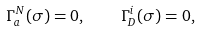Convert formula to latex. <formula><loc_0><loc_0><loc_500><loc_500>\Gamma ^ { N } _ { a } ( \sigma ) = 0 , \quad \Gamma ^ { i } _ { D } ( \sigma ) = 0 ,</formula> 